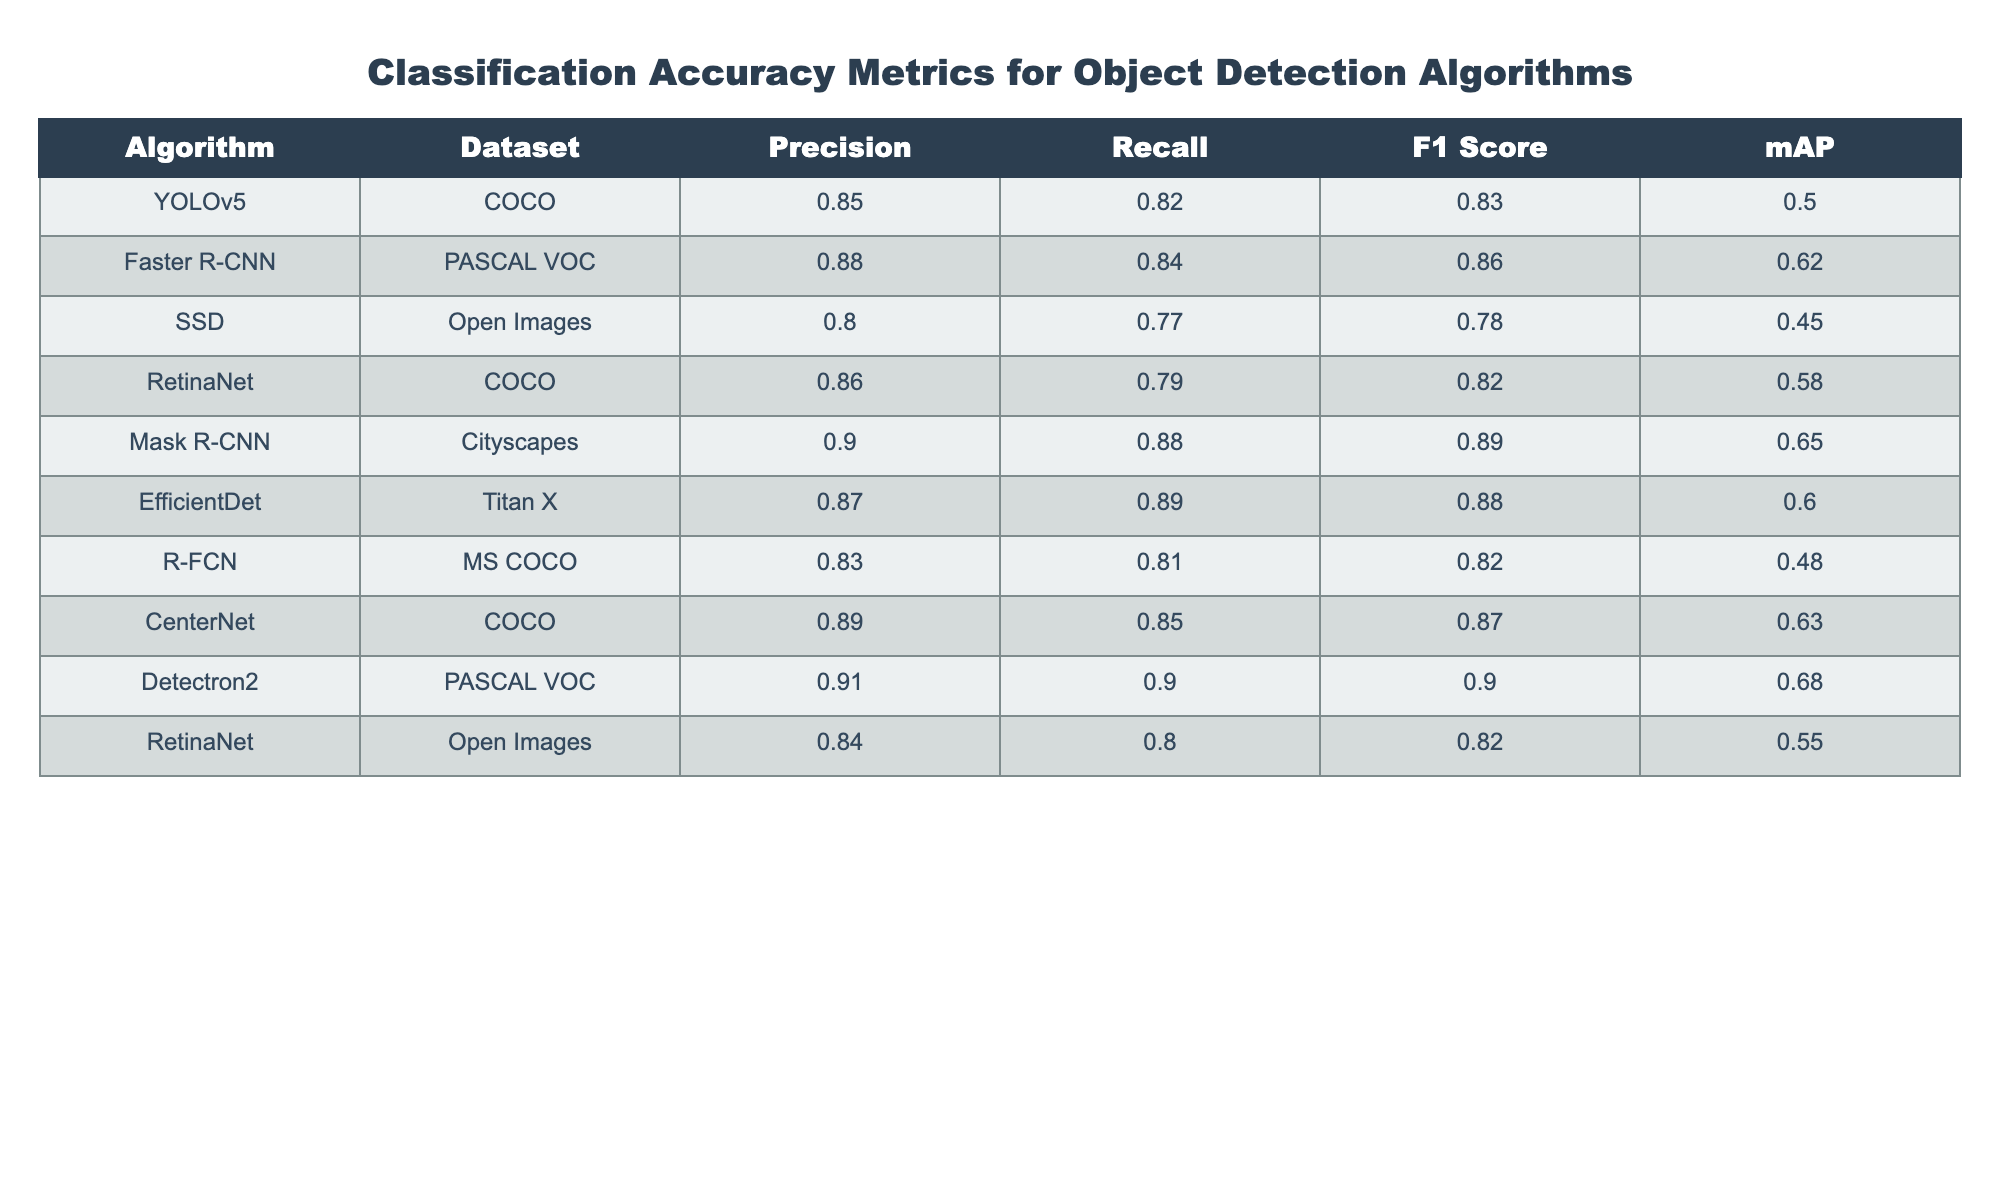What is the precision of the Mask R-CNN algorithm? The precision value for the Mask R-CNN algorithm is directly taken from the table under the Precision column, which states 0.90.
Answer: 0.90 What is the mean average precision (mAP) for all algorithms in the table? To compute the mean average precision, I will add all mAP values (0.50 + 0.62 + 0.45 + 0.58 + 0.65 + 0.60 + 0.48 + 0.63 + 0.68 + 0.55) which sums to 5.34, and then divide by the number of algorithms (10), resulting in 5.34/10 = 0.534.
Answer: 0.534 Did the Faster R-CNN algorithm achieve a recall greater than 0.80? By checking the Recall value for Faster R-CNN in the table, it is listed as 0.84, which is greater than 0.80. Hence, the statement is true.
Answer: Yes Which algorithm has the highest F1 Score? To find the highest F1 Score, I will compare each algorithm's F1 Score in the table. The values are: 0.83, 0.86, 0.78, 0.82, 0.89, 0.88, 0.82, 0.87, 0.90, and 0.82. The highest among these is 0.90 for the Detectron2 algorithm.
Answer: Detectron2 Is there an algorithm that has both precision and recall greater than 0.85? I will check each algorithm’s Precision and Recall values. Only the algorithms Detectron2 (Precision 0.91, Recall 0.90), Mask R-CNN (Precision 0.90, Recall 0.88), and CenterNet (Precision 0.89, Recall 0.85) satisfy the criteria. Therefore, the answer is true.
Answer: Yes What is the difference in mAP between the Detectron2 and the YOLOv5 algorithms? The mAP for Detectron2 is 0.68 and for YOLOv5 is 0.50. The difference is calculated by subtracting the mAP of YOLOv5 from that of Detectron2: 0.68 - 0.50 = 0.18.
Answer: 0.18 What is the average F1 Score of the algorithms that have a mAP greater than 0.55? First, identify the algorithms with mAP greater than 0.55: Faster R-CNN (0.62), RetinaNet (0.58), Mask R-CNN (0.65), EfficientDet (0.60), CenterNet (0.63), and Detectron2 (0.68). Their corresponding F1 Scores are 0.86, 0.82, 0.89, 0.88, 0.87, and 0.90; summing these gives 5.22. Dividing by the number of algorithms (6) yields an average F1 Score of 5.22 / 6 = 0.87.
Answer: 0.87 Which dataset had the lowest average precision across the different algorithms? I will check the Precision values grouped by datasets: COCO (0.85, 0.86, 0.89), PASCAL VOC (0.88, 0.91), Open Images (0.80, 0.84), Cityscapes (0.90), and Titan X (0.87). The average precision for each dataset is: COCO = (0.85 + 0.86 + 0.89)/3 = 0.867, PASCAL VOC = (0.88 + 0.91)/2 = 0.895, Open Images = (0.80 + 0.84)/2 = 0.82, Cityscapes = 0.90, Titan X = 0.87. The lowest average precision is for Open Images.
Answer: Open Images 